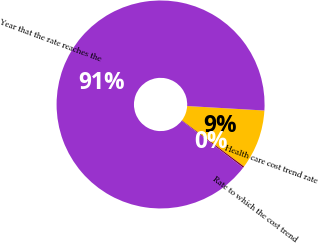Convert chart to OTSL. <chart><loc_0><loc_0><loc_500><loc_500><pie_chart><fcel>Health care cost trend rate<fcel>Rate to which the cost trend<fcel>Year that the rate reaches the<nl><fcel>9.25%<fcel>0.22%<fcel>90.52%<nl></chart> 